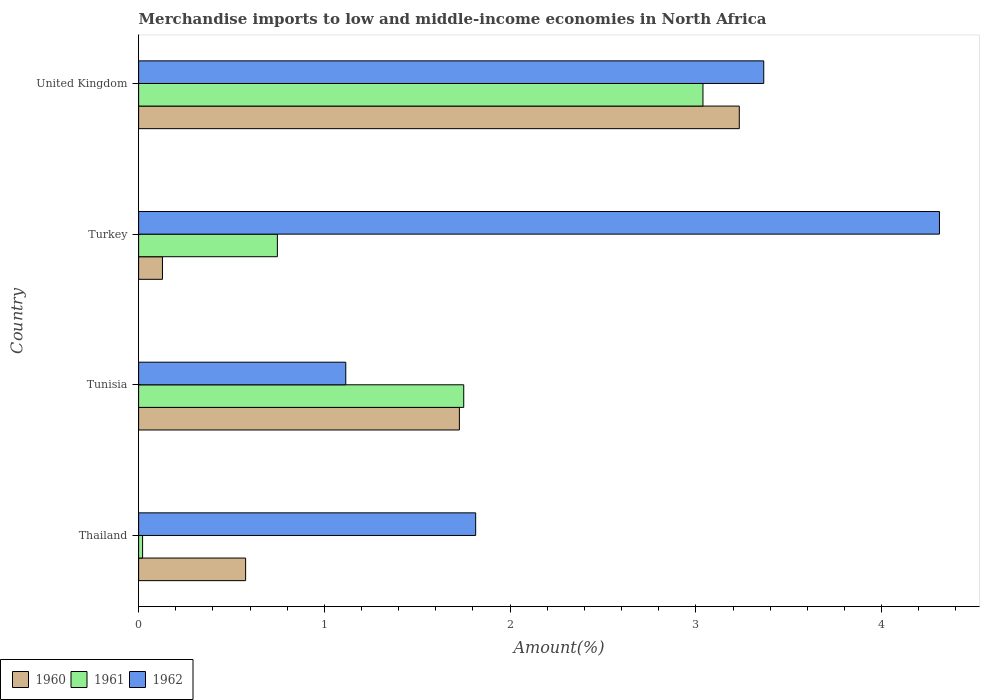How many different coloured bars are there?
Provide a short and direct response. 3. How many groups of bars are there?
Your answer should be very brief. 4. Are the number of bars on each tick of the Y-axis equal?
Offer a terse response. Yes. What is the label of the 4th group of bars from the top?
Offer a very short reply. Thailand. In how many cases, is the number of bars for a given country not equal to the number of legend labels?
Your answer should be very brief. 0. What is the percentage of amount earned from merchandise imports in 1962 in Tunisia?
Offer a terse response. 1.12. Across all countries, what is the maximum percentage of amount earned from merchandise imports in 1960?
Your answer should be very brief. 3.23. Across all countries, what is the minimum percentage of amount earned from merchandise imports in 1961?
Provide a succinct answer. 0.02. In which country was the percentage of amount earned from merchandise imports in 1961 maximum?
Provide a succinct answer. United Kingdom. In which country was the percentage of amount earned from merchandise imports in 1962 minimum?
Offer a very short reply. Tunisia. What is the total percentage of amount earned from merchandise imports in 1962 in the graph?
Provide a succinct answer. 10.61. What is the difference between the percentage of amount earned from merchandise imports in 1961 in Tunisia and that in Turkey?
Ensure brevity in your answer.  1. What is the difference between the percentage of amount earned from merchandise imports in 1962 in Tunisia and the percentage of amount earned from merchandise imports in 1961 in Turkey?
Give a very brief answer. 0.37. What is the average percentage of amount earned from merchandise imports in 1960 per country?
Keep it short and to the point. 1.42. What is the difference between the percentage of amount earned from merchandise imports in 1961 and percentage of amount earned from merchandise imports in 1962 in Thailand?
Provide a short and direct response. -1.79. What is the ratio of the percentage of amount earned from merchandise imports in 1960 in Thailand to that in Turkey?
Ensure brevity in your answer.  4.49. Is the difference between the percentage of amount earned from merchandise imports in 1961 in Thailand and United Kingdom greater than the difference between the percentage of amount earned from merchandise imports in 1962 in Thailand and United Kingdom?
Provide a short and direct response. No. What is the difference between the highest and the second highest percentage of amount earned from merchandise imports in 1961?
Your answer should be very brief. 1.29. What is the difference between the highest and the lowest percentage of amount earned from merchandise imports in 1961?
Ensure brevity in your answer.  3.02. In how many countries, is the percentage of amount earned from merchandise imports in 1960 greater than the average percentage of amount earned from merchandise imports in 1960 taken over all countries?
Your answer should be compact. 2. Is it the case that in every country, the sum of the percentage of amount earned from merchandise imports in 1961 and percentage of amount earned from merchandise imports in 1960 is greater than the percentage of amount earned from merchandise imports in 1962?
Your answer should be very brief. No. How many bars are there?
Keep it short and to the point. 12. Are all the bars in the graph horizontal?
Ensure brevity in your answer.  Yes. What is the title of the graph?
Keep it short and to the point. Merchandise imports to low and middle-income economies in North Africa. Does "1964" appear as one of the legend labels in the graph?
Your answer should be compact. No. What is the label or title of the X-axis?
Offer a very short reply. Amount(%). What is the label or title of the Y-axis?
Your answer should be compact. Country. What is the Amount(%) of 1960 in Thailand?
Offer a terse response. 0.58. What is the Amount(%) of 1961 in Thailand?
Provide a succinct answer. 0.02. What is the Amount(%) in 1962 in Thailand?
Give a very brief answer. 1.81. What is the Amount(%) of 1960 in Tunisia?
Give a very brief answer. 1.73. What is the Amount(%) in 1961 in Tunisia?
Provide a succinct answer. 1.75. What is the Amount(%) of 1962 in Tunisia?
Your answer should be compact. 1.12. What is the Amount(%) in 1960 in Turkey?
Keep it short and to the point. 0.13. What is the Amount(%) of 1961 in Turkey?
Keep it short and to the point. 0.75. What is the Amount(%) in 1962 in Turkey?
Your response must be concise. 4.31. What is the Amount(%) of 1960 in United Kingdom?
Your response must be concise. 3.23. What is the Amount(%) of 1961 in United Kingdom?
Your response must be concise. 3.04. What is the Amount(%) of 1962 in United Kingdom?
Your answer should be compact. 3.37. Across all countries, what is the maximum Amount(%) in 1960?
Provide a succinct answer. 3.23. Across all countries, what is the maximum Amount(%) in 1961?
Give a very brief answer. 3.04. Across all countries, what is the maximum Amount(%) of 1962?
Your answer should be very brief. 4.31. Across all countries, what is the minimum Amount(%) of 1960?
Ensure brevity in your answer.  0.13. Across all countries, what is the minimum Amount(%) of 1961?
Offer a terse response. 0.02. Across all countries, what is the minimum Amount(%) in 1962?
Your answer should be compact. 1.12. What is the total Amount(%) of 1960 in the graph?
Make the answer very short. 5.66. What is the total Amount(%) of 1961 in the graph?
Offer a very short reply. 5.56. What is the total Amount(%) in 1962 in the graph?
Make the answer very short. 10.61. What is the difference between the Amount(%) of 1960 in Thailand and that in Tunisia?
Keep it short and to the point. -1.15. What is the difference between the Amount(%) of 1961 in Thailand and that in Tunisia?
Your response must be concise. -1.73. What is the difference between the Amount(%) in 1962 in Thailand and that in Tunisia?
Offer a terse response. 0.7. What is the difference between the Amount(%) of 1960 in Thailand and that in Turkey?
Ensure brevity in your answer.  0.45. What is the difference between the Amount(%) of 1961 in Thailand and that in Turkey?
Your answer should be very brief. -0.73. What is the difference between the Amount(%) in 1962 in Thailand and that in Turkey?
Provide a succinct answer. -2.5. What is the difference between the Amount(%) in 1960 in Thailand and that in United Kingdom?
Offer a very short reply. -2.66. What is the difference between the Amount(%) of 1961 in Thailand and that in United Kingdom?
Ensure brevity in your answer.  -3.02. What is the difference between the Amount(%) in 1962 in Thailand and that in United Kingdom?
Offer a terse response. -1.55. What is the difference between the Amount(%) of 1960 in Tunisia and that in Turkey?
Make the answer very short. 1.6. What is the difference between the Amount(%) of 1962 in Tunisia and that in Turkey?
Keep it short and to the point. -3.2. What is the difference between the Amount(%) in 1960 in Tunisia and that in United Kingdom?
Your response must be concise. -1.51. What is the difference between the Amount(%) of 1961 in Tunisia and that in United Kingdom?
Provide a succinct answer. -1.29. What is the difference between the Amount(%) of 1962 in Tunisia and that in United Kingdom?
Offer a very short reply. -2.25. What is the difference between the Amount(%) of 1960 in Turkey and that in United Kingdom?
Make the answer very short. -3.11. What is the difference between the Amount(%) in 1961 in Turkey and that in United Kingdom?
Keep it short and to the point. -2.29. What is the difference between the Amount(%) of 1962 in Turkey and that in United Kingdom?
Provide a short and direct response. 0.95. What is the difference between the Amount(%) in 1960 in Thailand and the Amount(%) in 1961 in Tunisia?
Your answer should be very brief. -1.17. What is the difference between the Amount(%) in 1960 in Thailand and the Amount(%) in 1962 in Tunisia?
Your answer should be compact. -0.54. What is the difference between the Amount(%) in 1961 in Thailand and the Amount(%) in 1962 in Tunisia?
Provide a succinct answer. -1.09. What is the difference between the Amount(%) of 1960 in Thailand and the Amount(%) of 1961 in Turkey?
Your answer should be compact. -0.17. What is the difference between the Amount(%) in 1960 in Thailand and the Amount(%) in 1962 in Turkey?
Your response must be concise. -3.74. What is the difference between the Amount(%) in 1961 in Thailand and the Amount(%) in 1962 in Turkey?
Provide a short and direct response. -4.29. What is the difference between the Amount(%) in 1960 in Thailand and the Amount(%) in 1961 in United Kingdom?
Offer a very short reply. -2.46. What is the difference between the Amount(%) in 1960 in Thailand and the Amount(%) in 1962 in United Kingdom?
Keep it short and to the point. -2.79. What is the difference between the Amount(%) of 1961 in Thailand and the Amount(%) of 1962 in United Kingdom?
Provide a short and direct response. -3.34. What is the difference between the Amount(%) of 1960 in Tunisia and the Amount(%) of 1961 in Turkey?
Your answer should be very brief. 0.98. What is the difference between the Amount(%) of 1960 in Tunisia and the Amount(%) of 1962 in Turkey?
Make the answer very short. -2.58. What is the difference between the Amount(%) of 1961 in Tunisia and the Amount(%) of 1962 in Turkey?
Offer a terse response. -2.56. What is the difference between the Amount(%) of 1960 in Tunisia and the Amount(%) of 1961 in United Kingdom?
Keep it short and to the point. -1.31. What is the difference between the Amount(%) of 1960 in Tunisia and the Amount(%) of 1962 in United Kingdom?
Your response must be concise. -1.64. What is the difference between the Amount(%) in 1961 in Tunisia and the Amount(%) in 1962 in United Kingdom?
Provide a succinct answer. -1.62. What is the difference between the Amount(%) of 1960 in Turkey and the Amount(%) of 1961 in United Kingdom?
Provide a succinct answer. -2.91. What is the difference between the Amount(%) of 1960 in Turkey and the Amount(%) of 1962 in United Kingdom?
Offer a very short reply. -3.24. What is the difference between the Amount(%) in 1961 in Turkey and the Amount(%) in 1962 in United Kingdom?
Offer a terse response. -2.62. What is the average Amount(%) of 1960 per country?
Give a very brief answer. 1.42. What is the average Amount(%) of 1961 per country?
Provide a short and direct response. 1.39. What is the average Amount(%) of 1962 per country?
Your response must be concise. 2.65. What is the difference between the Amount(%) of 1960 and Amount(%) of 1961 in Thailand?
Your response must be concise. 0.55. What is the difference between the Amount(%) of 1960 and Amount(%) of 1962 in Thailand?
Your response must be concise. -1.24. What is the difference between the Amount(%) in 1961 and Amount(%) in 1962 in Thailand?
Offer a terse response. -1.79. What is the difference between the Amount(%) in 1960 and Amount(%) in 1961 in Tunisia?
Offer a terse response. -0.02. What is the difference between the Amount(%) in 1960 and Amount(%) in 1962 in Tunisia?
Provide a succinct answer. 0.61. What is the difference between the Amount(%) in 1961 and Amount(%) in 1962 in Tunisia?
Keep it short and to the point. 0.64. What is the difference between the Amount(%) in 1960 and Amount(%) in 1961 in Turkey?
Your answer should be very brief. -0.62. What is the difference between the Amount(%) in 1960 and Amount(%) in 1962 in Turkey?
Keep it short and to the point. -4.18. What is the difference between the Amount(%) in 1961 and Amount(%) in 1962 in Turkey?
Offer a very short reply. -3.56. What is the difference between the Amount(%) in 1960 and Amount(%) in 1961 in United Kingdom?
Offer a terse response. 0.2. What is the difference between the Amount(%) in 1960 and Amount(%) in 1962 in United Kingdom?
Provide a short and direct response. -0.13. What is the difference between the Amount(%) of 1961 and Amount(%) of 1962 in United Kingdom?
Provide a short and direct response. -0.33. What is the ratio of the Amount(%) in 1960 in Thailand to that in Tunisia?
Ensure brevity in your answer.  0.33. What is the ratio of the Amount(%) in 1961 in Thailand to that in Tunisia?
Offer a terse response. 0.01. What is the ratio of the Amount(%) of 1962 in Thailand to that in Tunisia?
Offer a terse response. 1.63. What is the ratio of the Amount(%) of 1960 in Thailand to that in Turkey?
Your response must be concise. 4.49. What is the ratio of the Amount(%) of 1961 in Thailand to that in Turkey?
Provide a short and direct response. 0.03. What is the ratio of the Amount(%) of 1962 in Thailand to that in Turkey?
Offer a very short reply. 0.42. What is the ratio of the Amount(%) in 1960 in Thailand to that in United Kingdom?
Ensure brevity in your answer.  0.18. What is the ratio of the Amount(%) in 1961 in Thailand to that in United Kingdom?
Provide a short and direct response. 0.01. What is the ratio of the Amount(%) of 1962 in Thailand to that in United Kingdom?
Ensure brevity in your answer.  0.54. What is the ratio of the Amount(%) of 1960 in Tunisia to that in Turkey?
Make the answer very short. 13.46. What is the ratio of the Amount(%) of 1961 in Tunisia to that in Turkey?
Offer a very short reply. 2.34. What is the ratio of the Amount(%) of 1962 in Tunisia to that in Turkey?
Ensure brevity in your answer.  0.26. What is the ratio of the Amount(%) of 1960 in Tunisia to that in United Kingdom?
Provide a succinct answer. 0.53. What is the ratio of the Amount(%) of 1961 in Tunisia to that in United Kingdom?
Provide a succinct answer. 0.58. What is the ratio of the Amount(%) in 1962 in Tunisia to that in United Kingdom?
Keep it short and to the point. 0.33. What is the ratio of the Amount(%) of 1960 in Turkey to that in United Kingdom?
Provide a succinct answer. 0.04. What is the ratio of the Amount(%) in 1961 in Turkey to that in United Kingdom?
Offer a terse response. 0.25. What is the ratio of the Amount(%) in 1962 in Turkey to that in United Kingdom?
Your response must be concise. 1.28. What is the difference between the highest and the second highest Amount(%) of 1960?
Your response must be concise. 1.51. What is the difference between the highest and the second highest Amount(%) in 1961?
Provide a succinct answer. 1.29. What is the difference between the highest and the second highest Amount(%) in 1962?
Offer a very short reply. 0.95. What is the difference between the highest and the lowest Amount(%) in 1960?
Make the answer very short. 3.11. What is the difference between the highest and the lowest Amount(%) of 1961?
Your answer should be compact. 3.02. What is the difference between the highest and the lowest Amount(%) in 1962?
Provide a short and direct response. 3.2. 